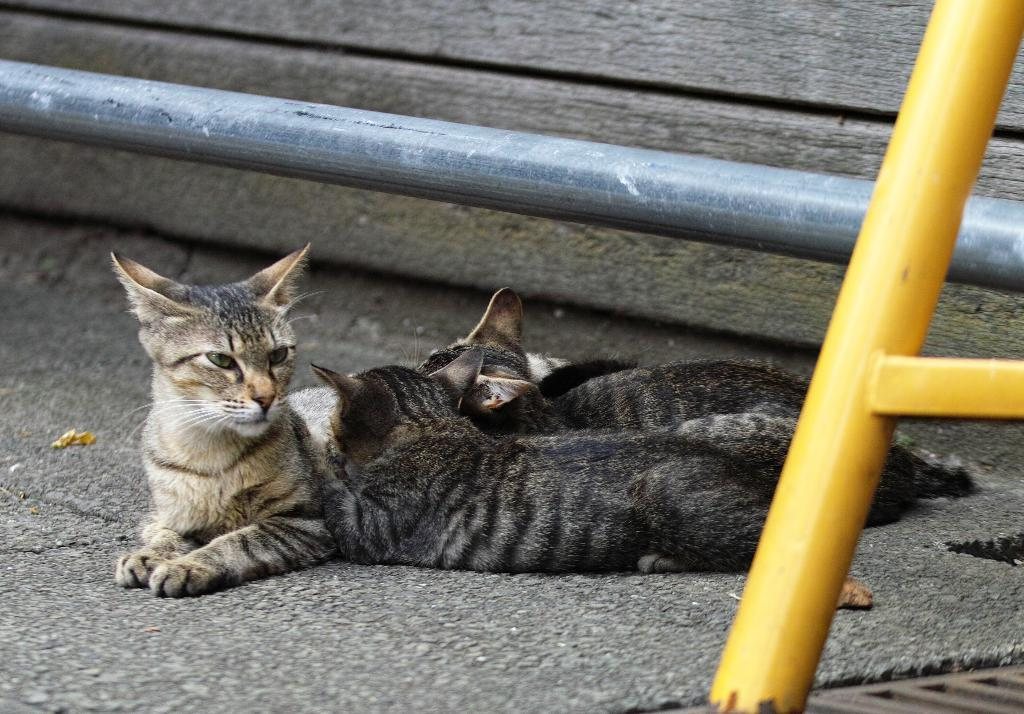What type of animals are present in the image? There are cats in the image. What material are the pipes made of in the image? The pipes in the image are made of metal. What rule is being enforced by the cats in the image? There is no indication in the image that the cats are enforcing any rules. How are the cats sorting the metal pipes in the image? There is no indication in the image that the cats are sorting any metal pipes. 